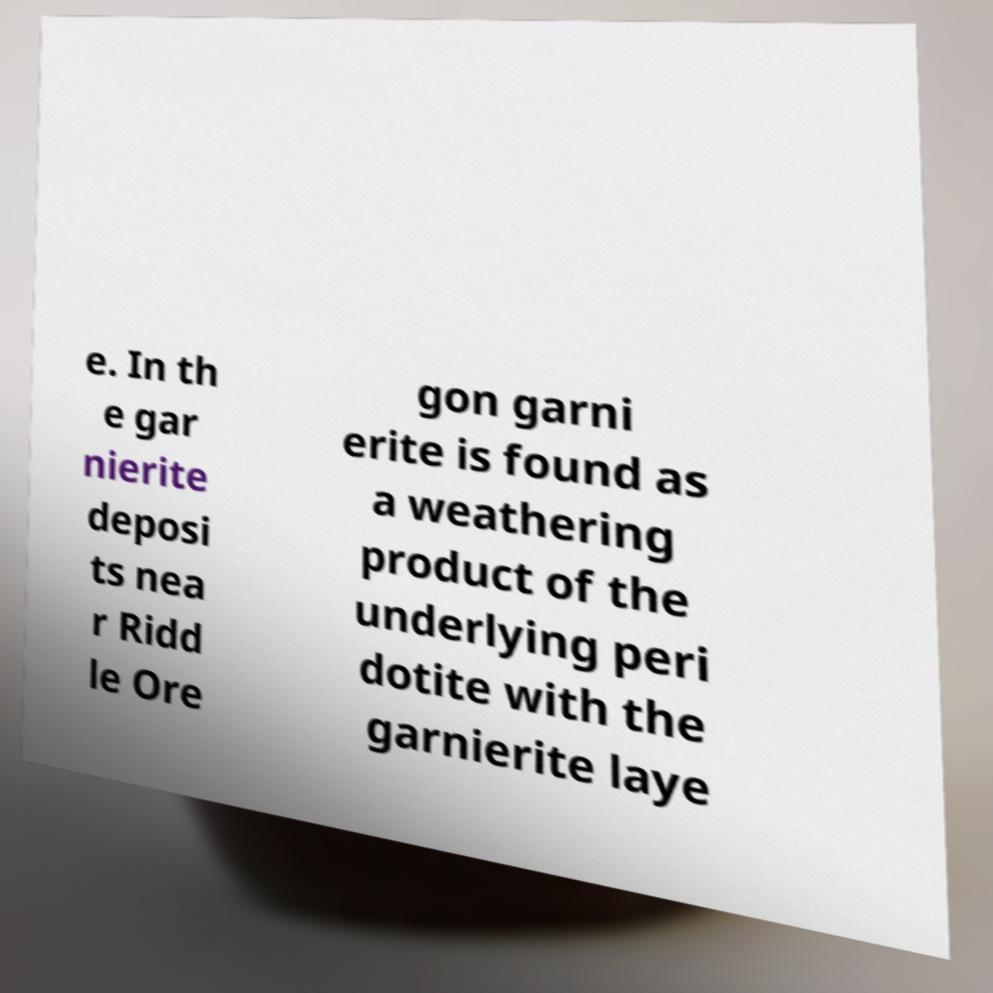For documentation purposes, I need the text within this image transcribed. Could you provide that? e. In th e gar nierite deposi ts nea r Ridd le Ore gon garni erite is found as a weathering product of the underlying peri dotite with the garnierite laye 